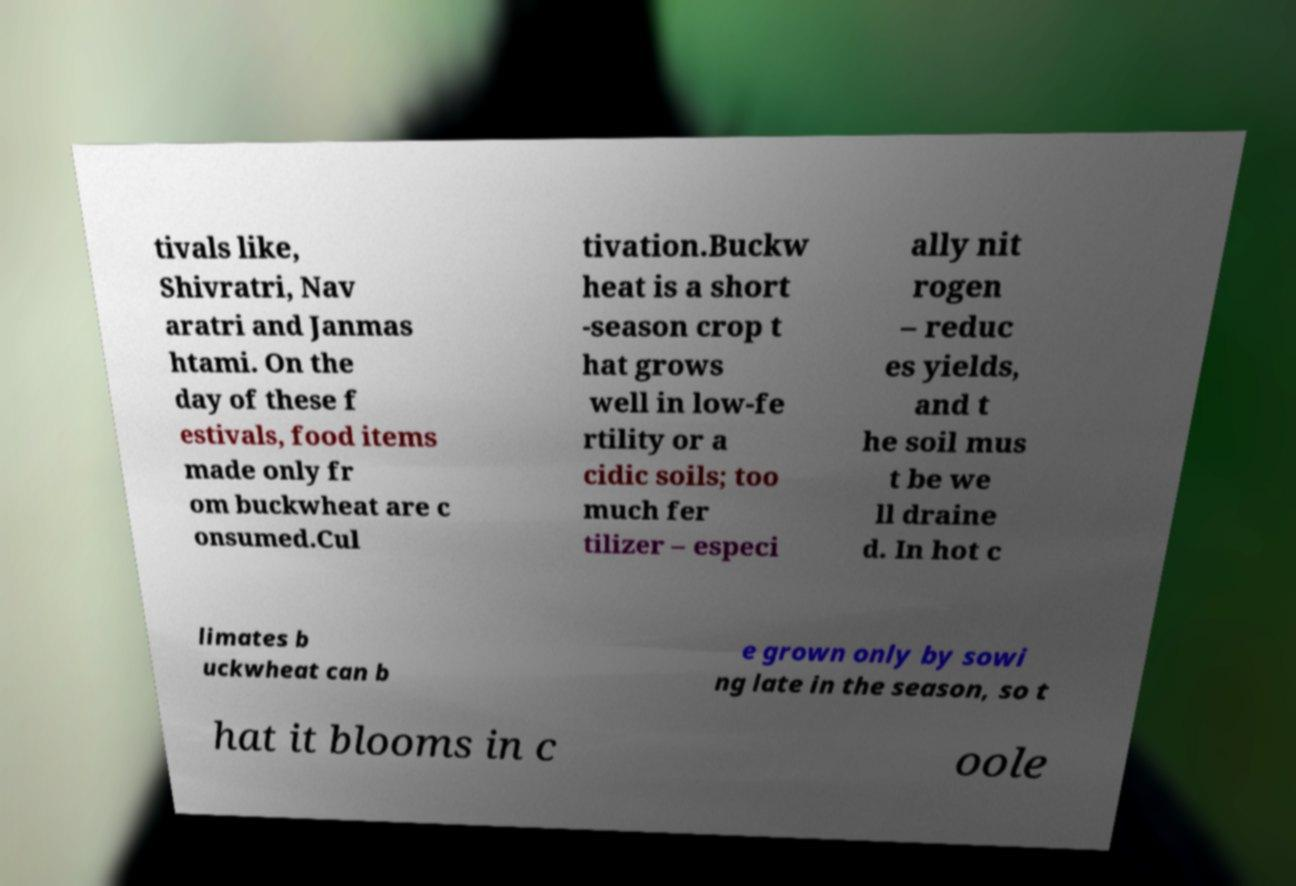Could you extract and type out the text from this image? tivals like, Shivratri, Nav aratri and Janmas htami. On the day of these f estivals, food items made only fr om buckwheat are c onsumed.Cul tivation.Buckw heat is a short -season crop t hat grows well in low-fe rtility or a cidic soils; too much fer tilizer – especi ally nit rogen – reduc es yields, and t he soil mus t be we ll draine d. In hot c limates b uckwheat can b e grown only by sowi ng late in the season, so t hat it blooms in c oole 